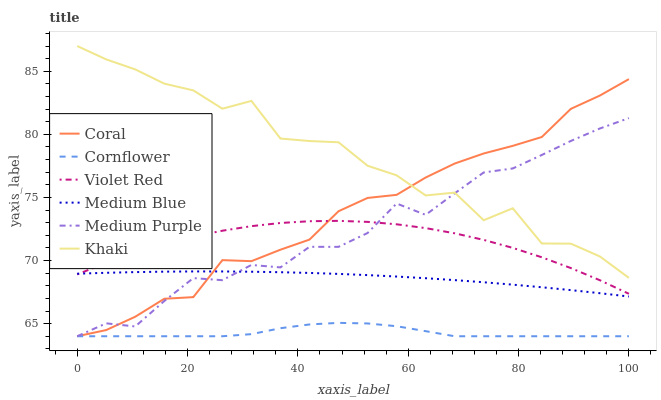Does Cornflower have the minimum area under the curve?
Answer yes or no. Yes. Does Khaki have the maximum area under the curve?
Answer yes or no. Yes. Does Violet Red have the minimum area under the curve?
Answer yes or no. No. Does Violet Red have the maximum area under the curve?
Answer yes or no. No. Is Medium Blue the smoothest?
Answer yes or no. Yes. Is Khaki the roughest?
Answer yes or no. Yes. Is Violet Red the smoothest?
Answer yes or no. No. Is Violet Red the roughest?
Answer yes or no. No. Does Cornflower have the lowest value?
Answer yes or no. Yes. Does Violet Red have the lowest value?
Answer yes or no. No. Does Khaki have the highest value?
Answer yes or no. Yes. Does Violet Red have the highest value?
Answer yes or no. No. Is Cornflower less than Violet Red?
Answer yes or no. Yes. Is Violet Red greater than Cornflower?
Answer yes or no. Yes. Does Medium Blue intersect Violet Red?
Answer yes or no. Yes. Is Medium Blue less than Violet Red?
Answer yes or no. No. Is Medium Blue greater than Violet Red?
Answer yes or no. No. Does Cornflower intersect Violet Red?
Answer yes or no. No. 